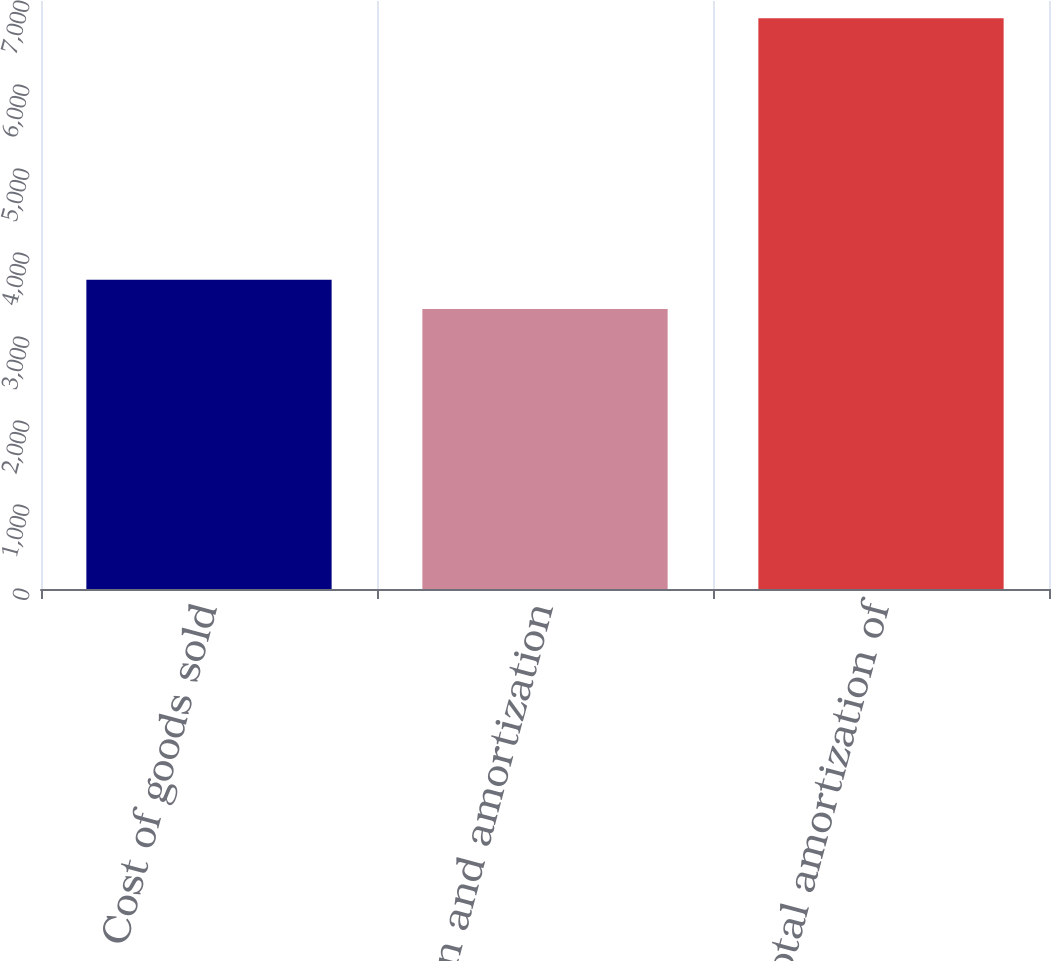<chart> <loc_0><loc_0><loc_500><loc_500><bar_chart><fcel>Cost of goods sold<fcel>Depreciation and amortization<fcel>Total amortization of<nl><fcel>3680.2<fcel>3334<fcel>6796<nl></chart> 